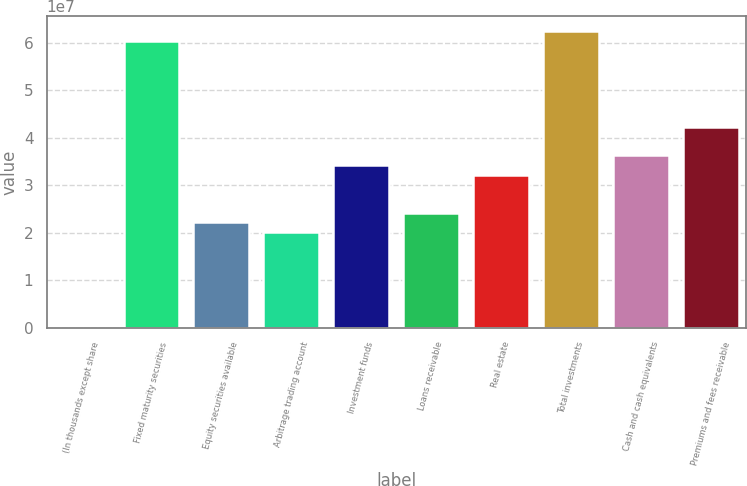Convert chart to OTSL. <chart><loc_0><loc_0><loc_500><loc_500><bar_chart><fcel>(In thousands except share<fcel>Fixed maturity securities<fcel>Equity securities available<fcel>Arbitrage trading account<fcel>Investment funds<fcel>Loans receivable<fcel>Real estate<fcel>Total investments<fcel>Cash and cash equivalents<fcel>Premiums and fees receivable<nl><fcel>2012<fcel>6.04637e+07<fcel>2.21713e+07<fcel>2.01559e+07<fcel>3.42636e+07<fcel>2.41867e+07<fcel>3.22482e+07<fcel>6.24791e+07<fcel>3.6279e+07<fcel>4.23252e+07<nl></chart> 